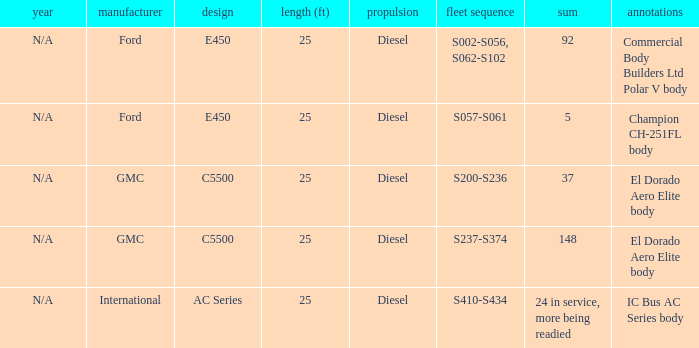What are the notes for Ford when the total is 5? Champion CH-251FL body. 